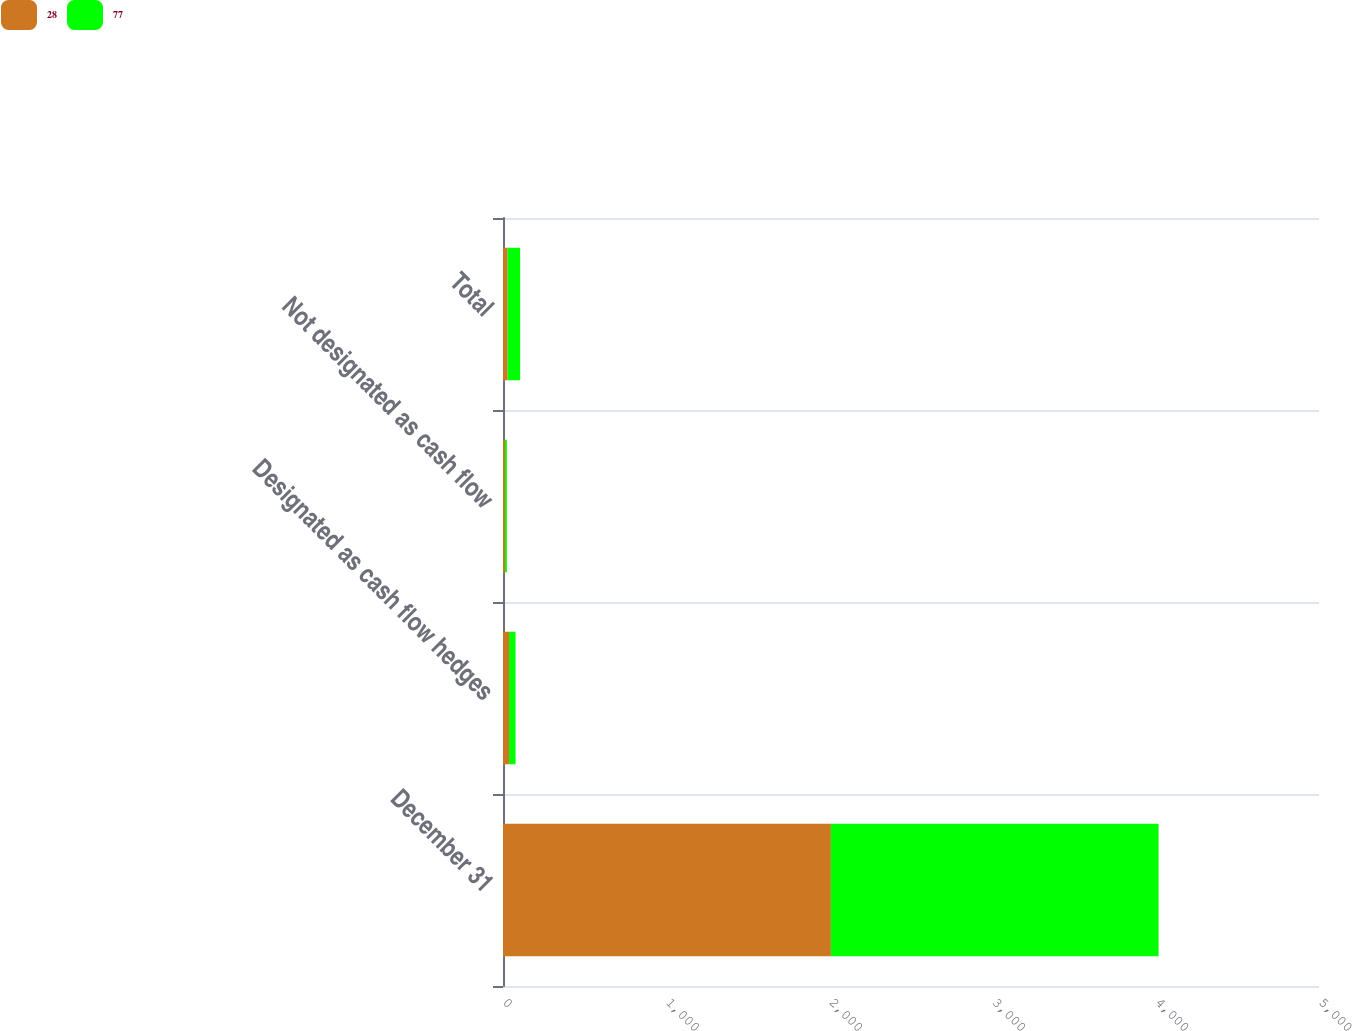Convert chart to OTSL. <chart><loc_0><loc_0><loc_500><loc_500><stacked_bar_chart><ecel><fcel>December 31<fcel>Designated as cash flow hedges<fcel>Not designated as cash flow<fcel>Total<nl><fcel>28<fcel>2009<fcel>37<fcel>12<fcel>28<nl><fcel>77<fcel>2008<fcel>40<fcel>12<fcel>77<nl></chart> 